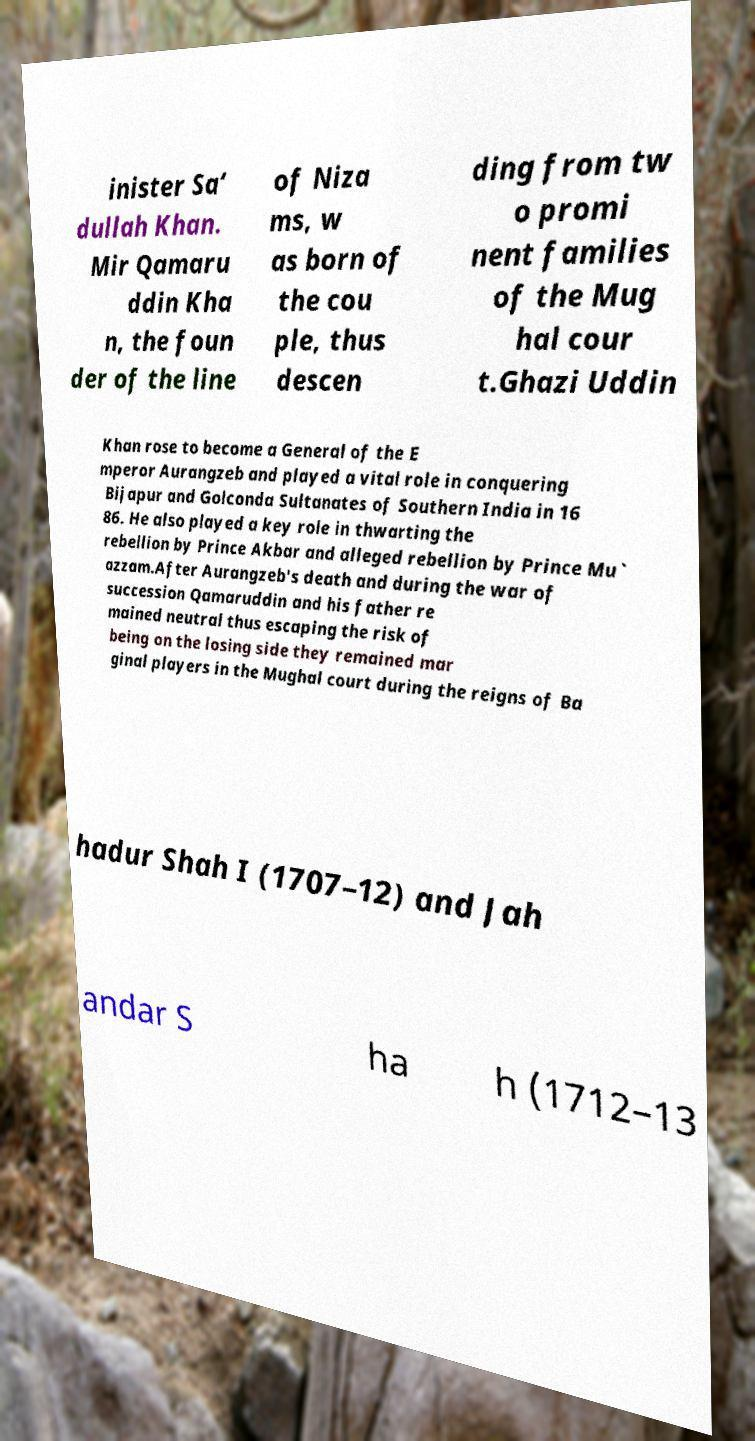There's text embedded in this image that I need extracted. Can you transcribe it verbatim? inister Sa‘ dullah Khan. Mir Qamaru ddin Kha n, the foun der of the line of Niza ms, w as born of the cou ple, thus descen ding from tw o promi nent families of the Mug hal cour t.Ghazi Uddin Khan rose to become a General of the E mperor Aurangzeb and played a vital role in conquering Bijapur and Golconda Sultanates of Southern India in 16 86. He also played a key role in thwarting the rebellion by Prince Akbar and alleged rebellion by Prince Mu` azzam.After Aurangzeb's death and during the war of succession Qamaruddin and his father re mained neutral thus escaping the risk of being on the losing side they remained mar ginal players in the Mughal court during the reigns of Ba hadur Shah I (1707–12) and Jah andar S ha h (1712–13 